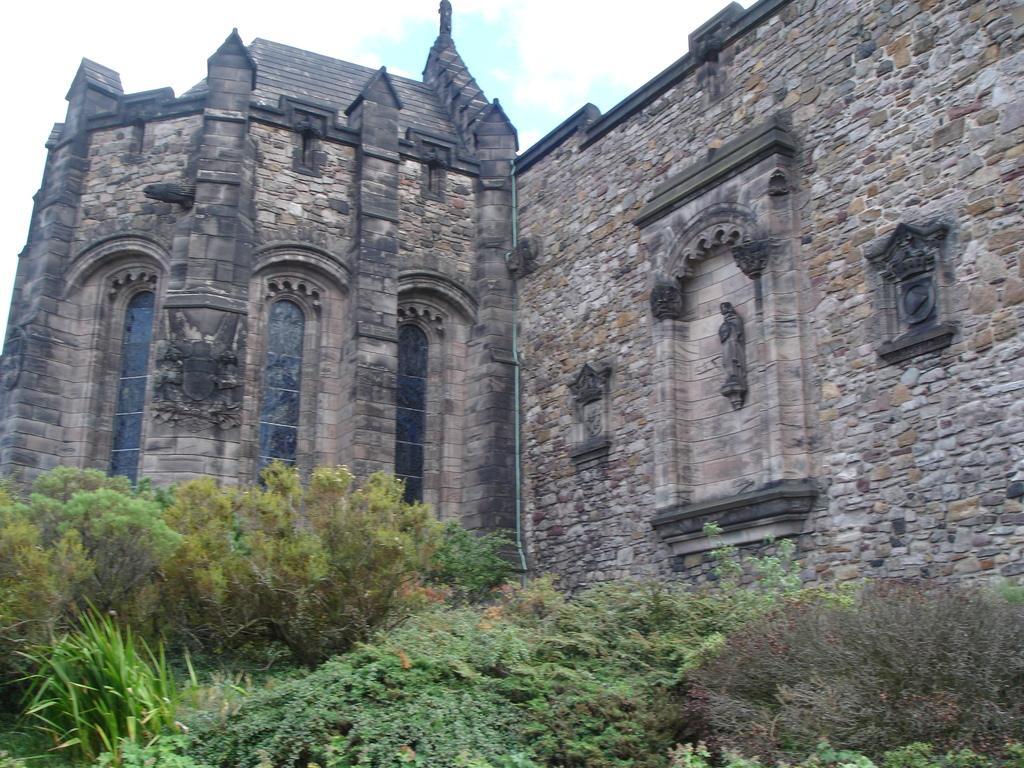Please provide a concise description of this image. In this image there is a building in middle of this image and there are some trees in bottom of this image and there is a sky at top of this image. 